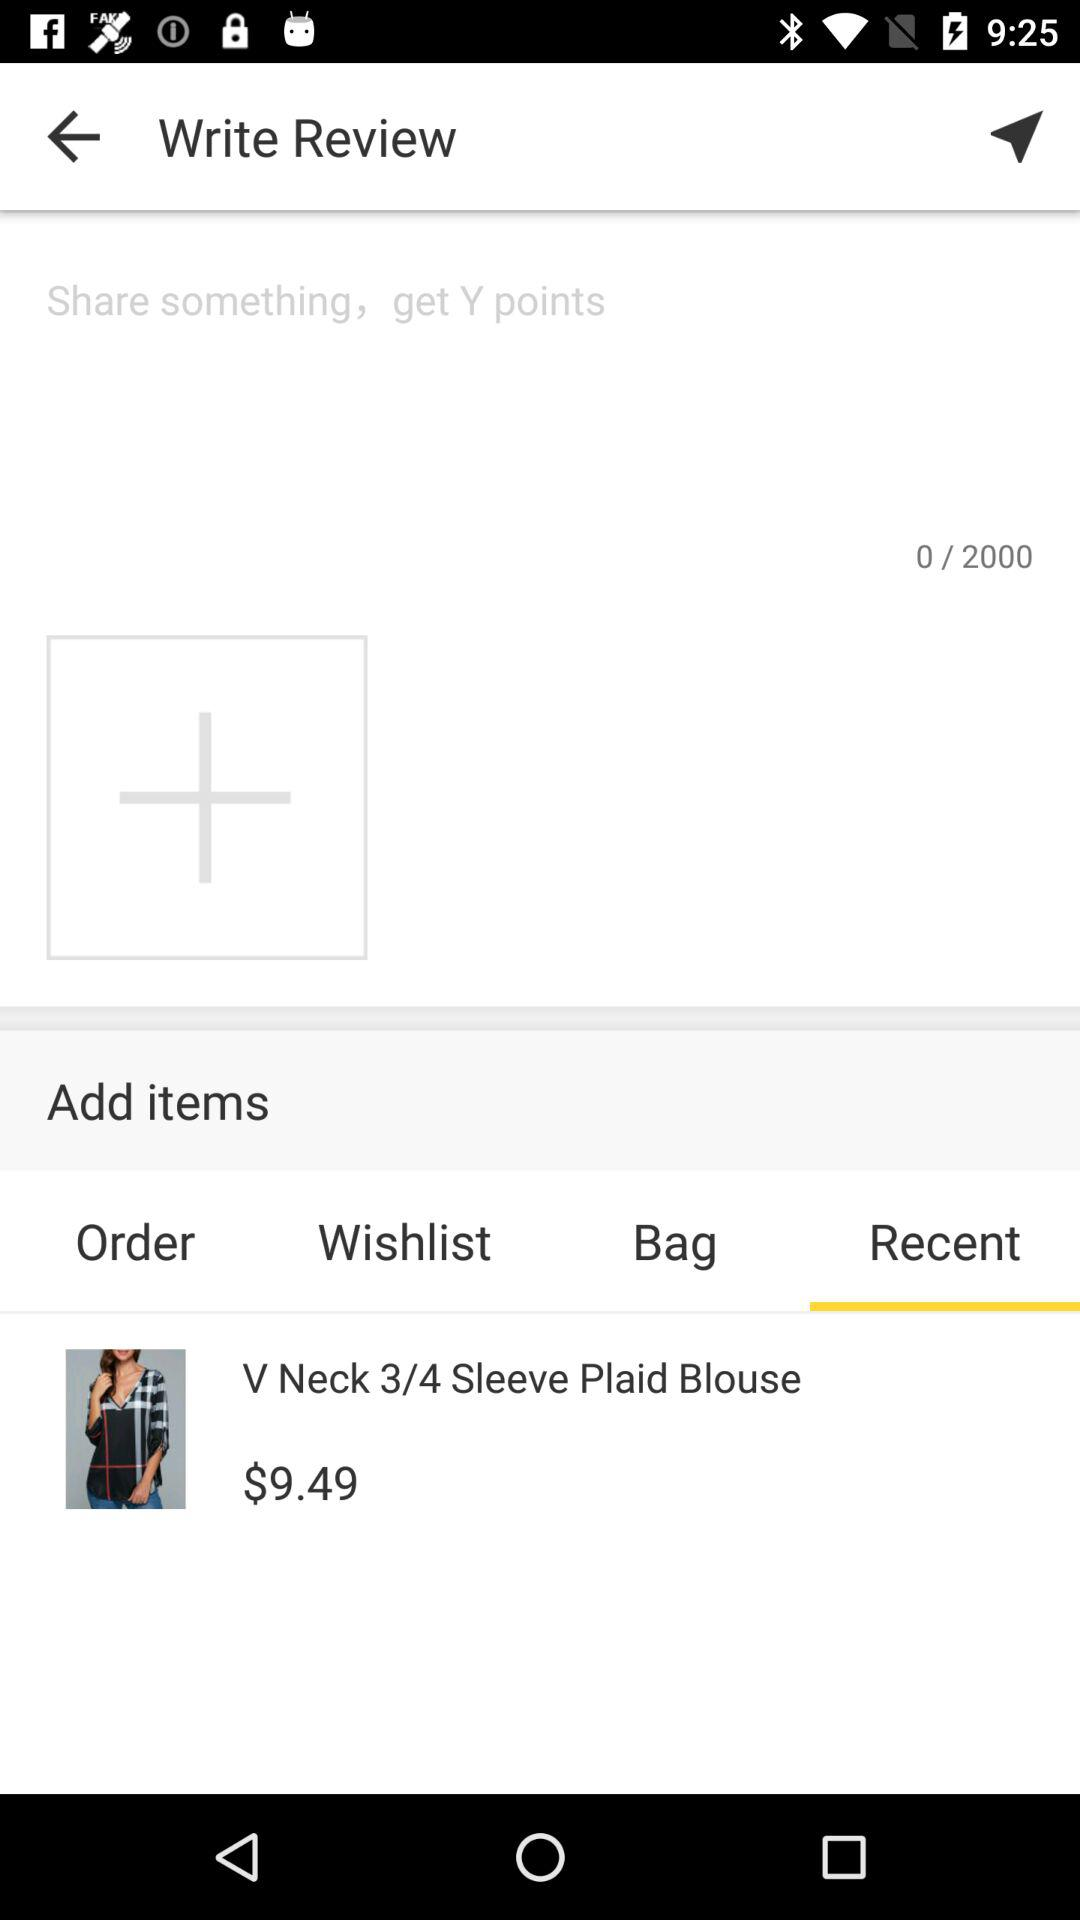How many points can I earn by writing a review?
Answer the question using a single word or phrase. Y 